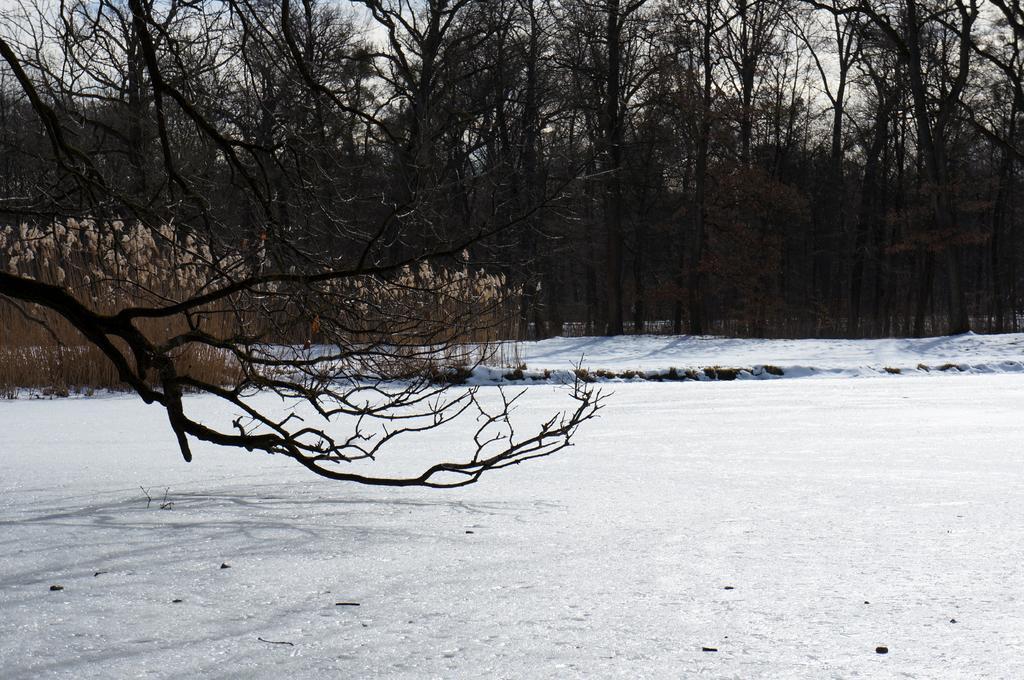Can you describe this image briefly? In this picture, we can see the ground with snow, and we can see plants, trees, and the sky with clouds. 